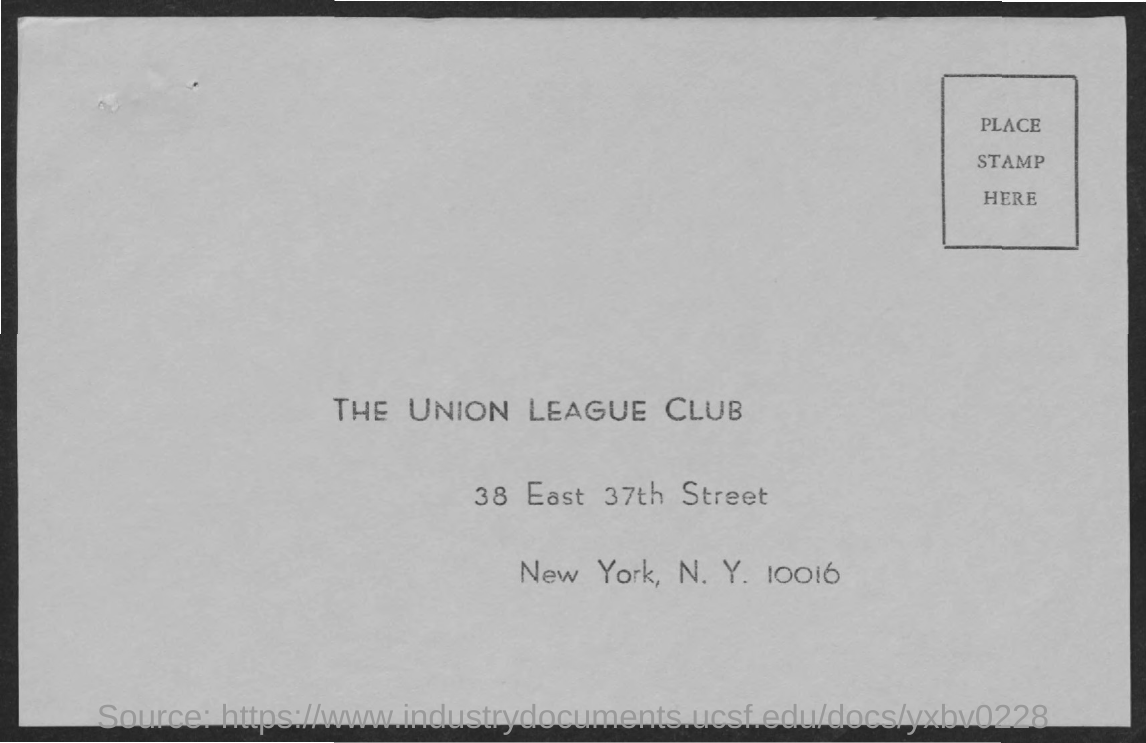Mention a couple of crucial points in this snapshot. The name of the club mentioned is the Union League Club. 38 East 37th Street is a street that exists. 